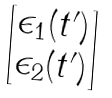<formula> <loc_0><loc_0><loc_500><loc_500>\begin{bmatrix} \epsilon _ { 1 } ( t ^ { \prime } ) \\ \epsilon _ { 2 } ( t ^ { \prime } ) \end{bmatrix}</formula> 